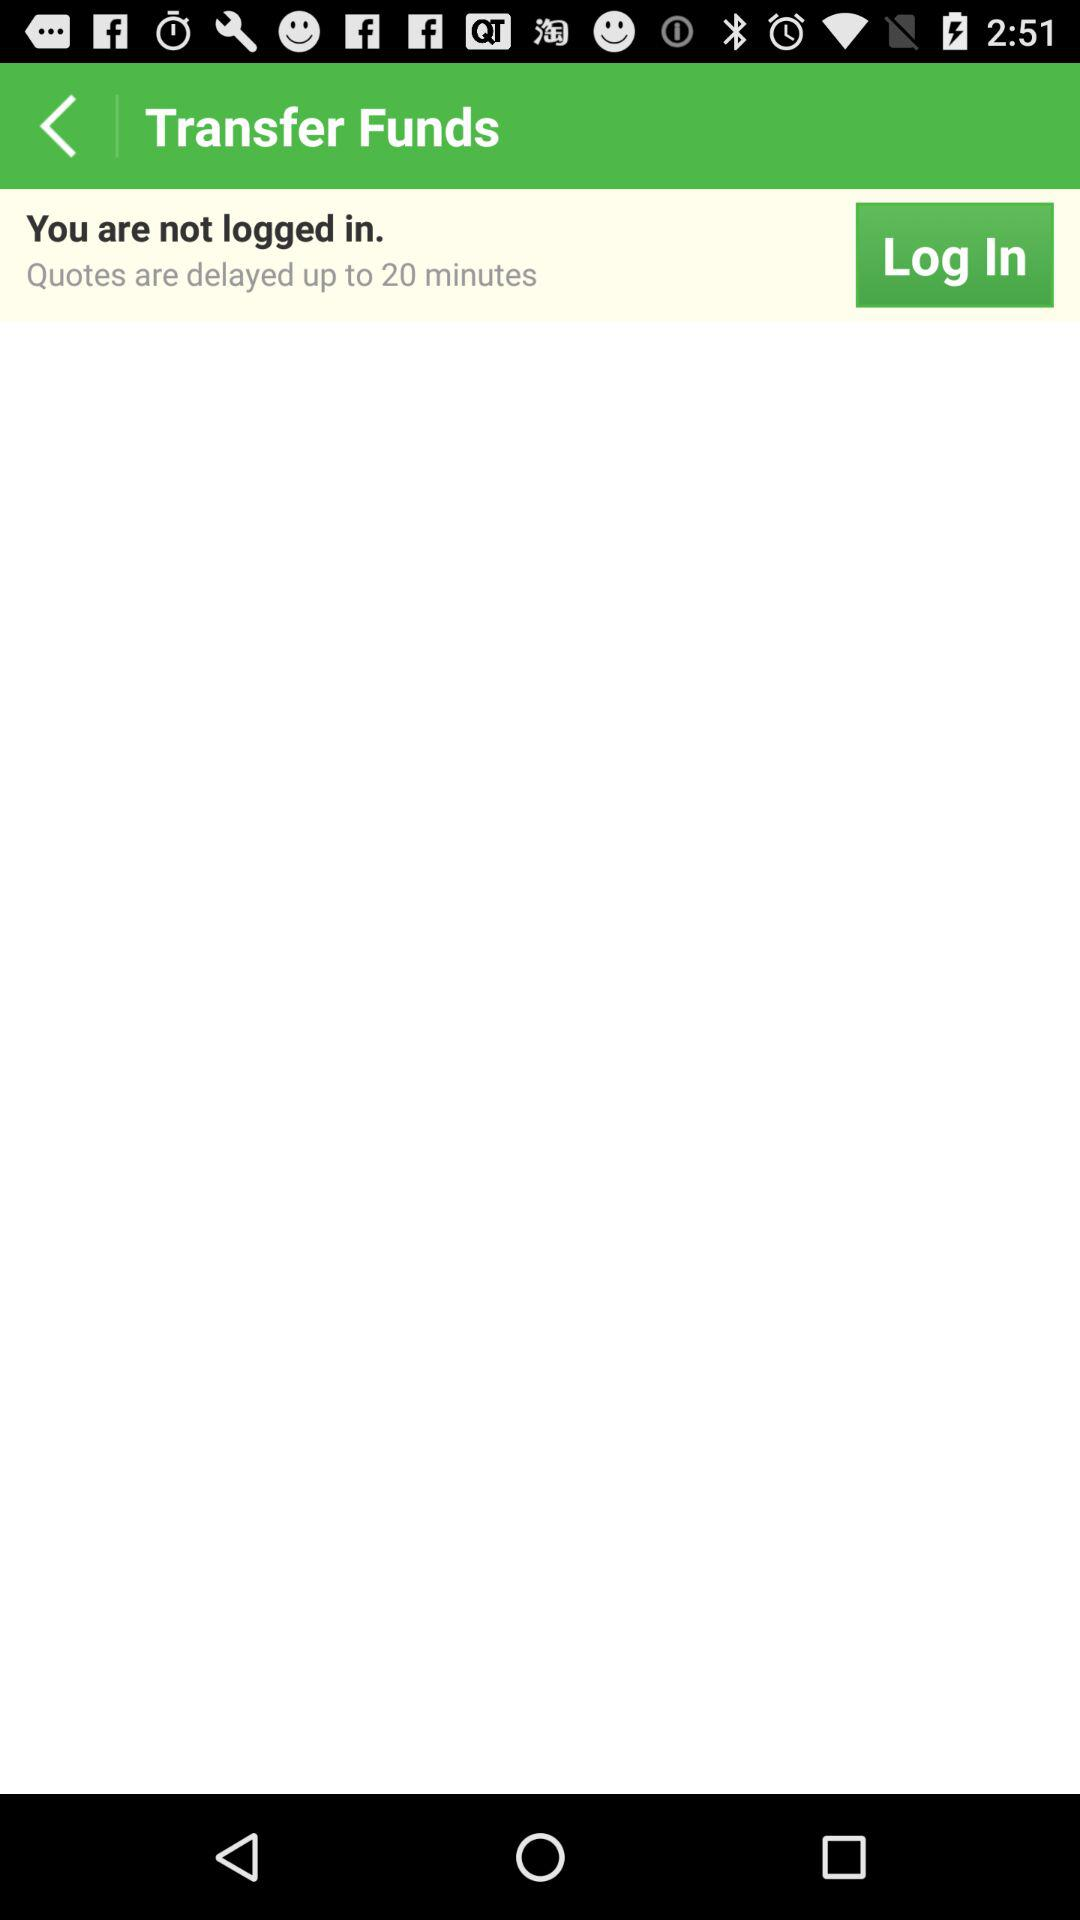Why are quotes delayed up to 20 minutes?
When the provided information is insufficient, respond with <no answer>. <no answer> 